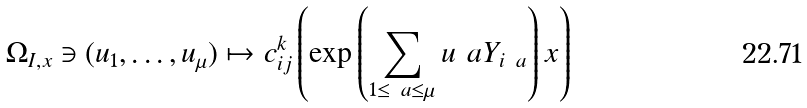<formula> <loc_0><loc_0><loc_500><loc_500>\Omega _ { I , x } \ni ( u _ { 1 } , \dots , u _ { \mu } ) \mapsto c _ { i j } ^ { k } \left ( \exp \left ( \sum _ { 1 \leq \ a \leq \mu } u _ { \ } a Y _ { i _ { \ } a } \right ) x \right )</formula> 